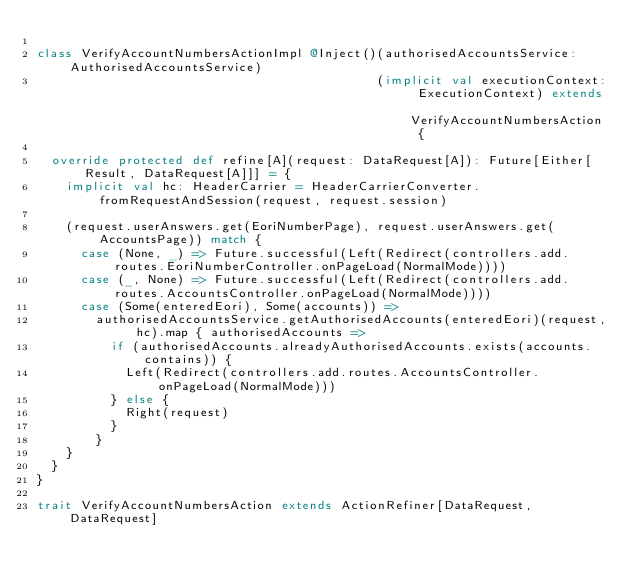Convert code to text. <code><loc_0><loc_0><loc_500><loc_500><_Scala_>
class VerifyAccountNumbersActionImpl @Inject()(authorisedAccountsService: AuthorisedAccountsService)
                                              (implicit val executionContext: ExecutionContext) extends VerifyAccountNumbersAction {

  override protected def refine[A](request: DataRequest[A]): Future[Either[Result, DataRequest[A]]] = {
    implicit val hc: HeaderCarrier = HeaderCarrierConverter.fromRequestAndSession(request, request.session)

    (request.userAnswers.get(EoriNumberPage), request.userAnswers.get(AccountsPage)) match {
      case (None, _) => Future.successful(Left(Redirect(controllers.add.routes.EoriNumberController.onPageLoad(NormalMode))))
      case (_, None) => Future.successful(Left(Redirect(controllers.add.routes.AccountsController.onPageLoad(NormalMode))))
      case (Some(enteredEori), Some(accounts)) =>
        authorisedAccountsService.getAuthorisedAccounts(enteredEori)(request, hc).map { authorisedAccounts =>
          if (authorisedAccounts.alreadyAuthorisedAccounts.exists(accounts.contains)) {
            Left(Redirect(controllers.add.routes.AccountsController.onPageLoad(NormalMode)))
          } else {
            Right(request)
          }
        }
    }
  }
}

trait VerifyAccountNumbersAction extends ActionRefiner[DataRequest, DataRequest]
</code> 